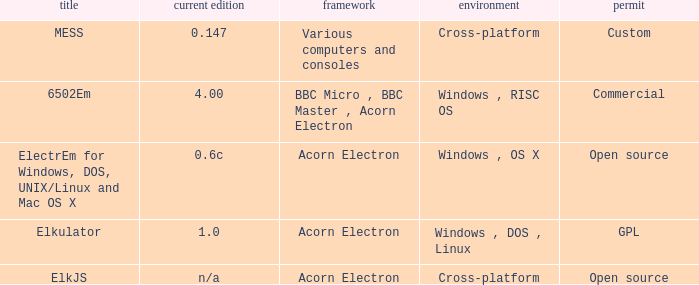What is the name of the platform used for various computers and consoles? Cross-platform. 